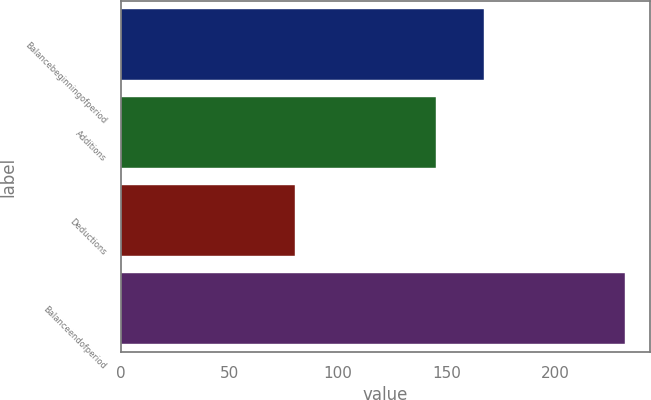Convert chart to OTSL. <chart><loc_0><loc_0><loc_500><loc_500><bar_chart><fcel>Balancebeginningofperiod<fcel>Additions<fcel>Deductions<fcel>Balanceendofperiod<nl><fcel>167<fcel>145<fcel>80<fcel>232<nl></chart> 